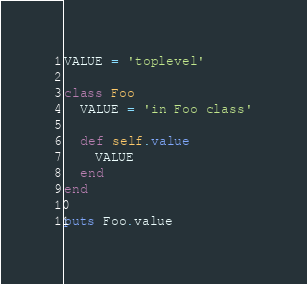<code> <loc_0><loc_0><loc_500><loc_500><_Ruby_>VALUE = 'toplevel'

class Foo
  VALUE = 'in Foo class'

  def self.value
    VALUE
  end
end

puts Foo.value</code> 